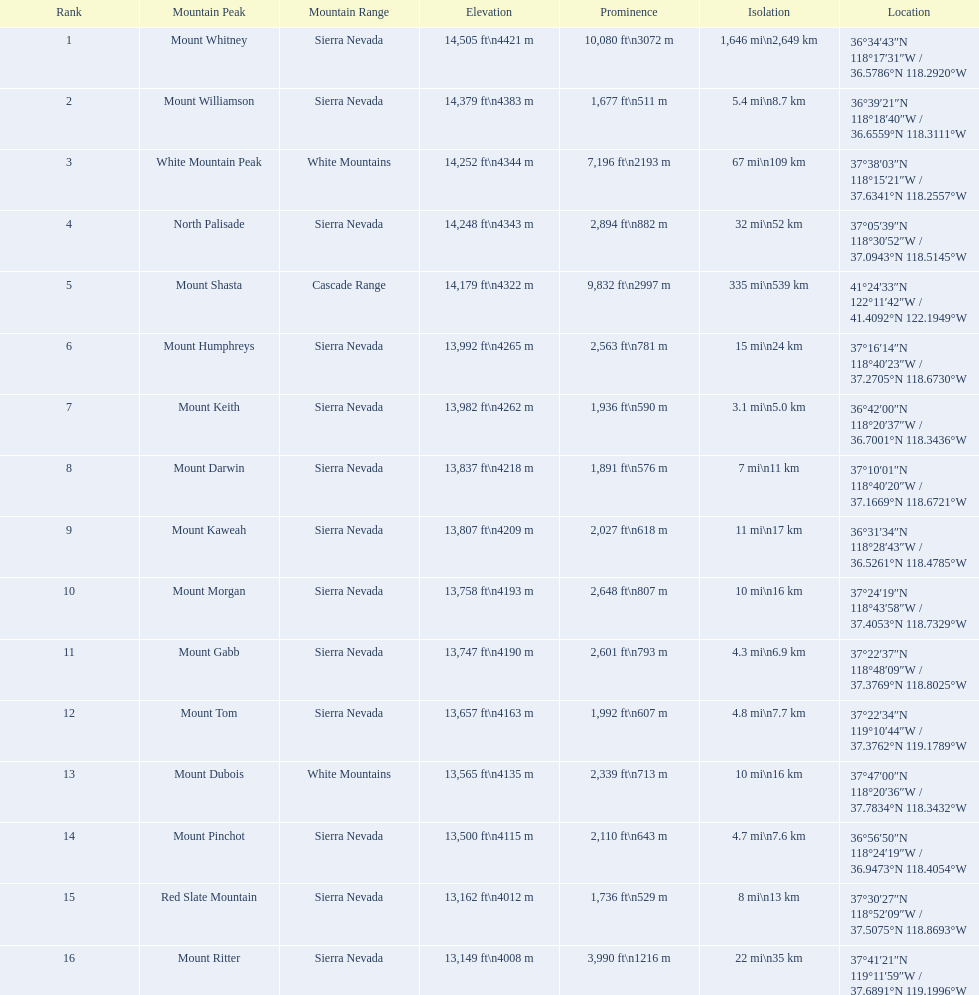What are the mentioned heights? 14,505 ft\n4421 m, 14,379 ft\n4383 m, 14,252 ft\n4344 m, 14,248 ft\n4343 m, 14,179 ft\n4322 m, 13,992 ft\n4265 m, 13,982 ft\n4262 m, 13,837 ft\n4218 m, 13,807 ft\n4209 m, 13,758 ft\n4193 m, 13,747 ft\n4190 m, 13,657 ft\n4163 m, 13,565 ft\n4135 m, 13,500 ft\n4115 m, 13,162 ft\n4012 m, 13,149 ft\n4008 m. Which one is equal to or less than 13,149 feet? 13,149 ft\n4008 m. Which mountain peak is associated with that elevation? Mount Ritter. 